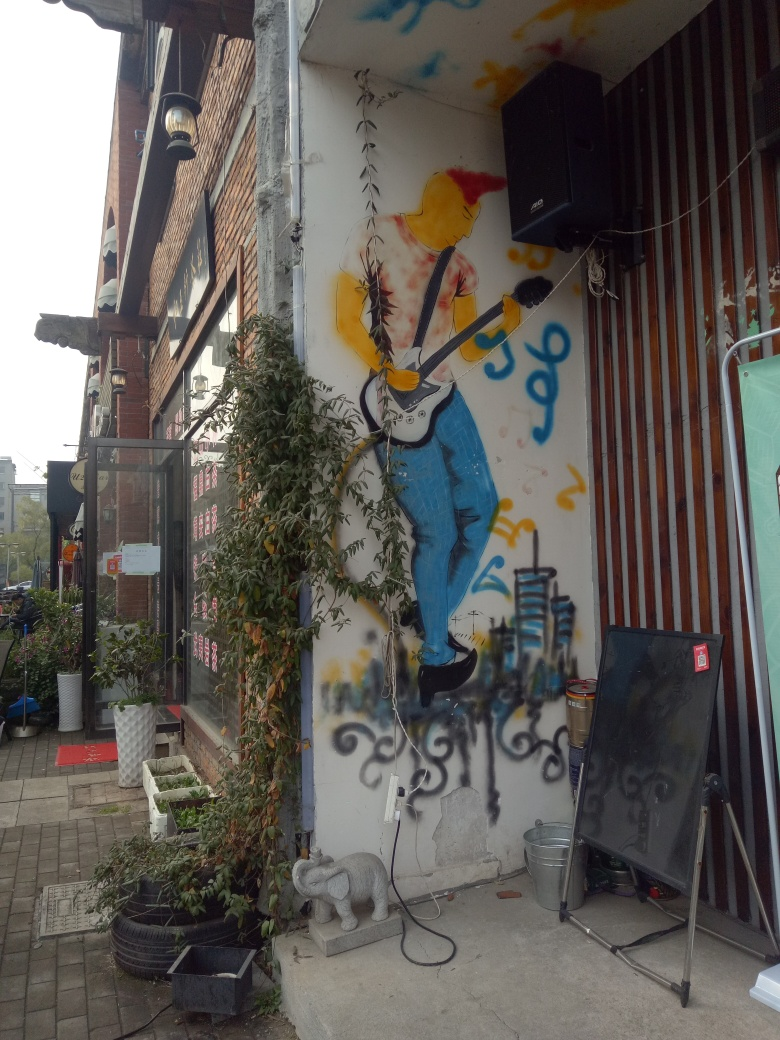What's the theme of this mural? The mural depicts a vibrant street art piece featuring a figure playing a guitar. The theme seems to celebrate music and possibly street performance, as the setting suggests an urban environment. The use of bright colors and dynamic forms adds to the energetic vibe of the artwork. 